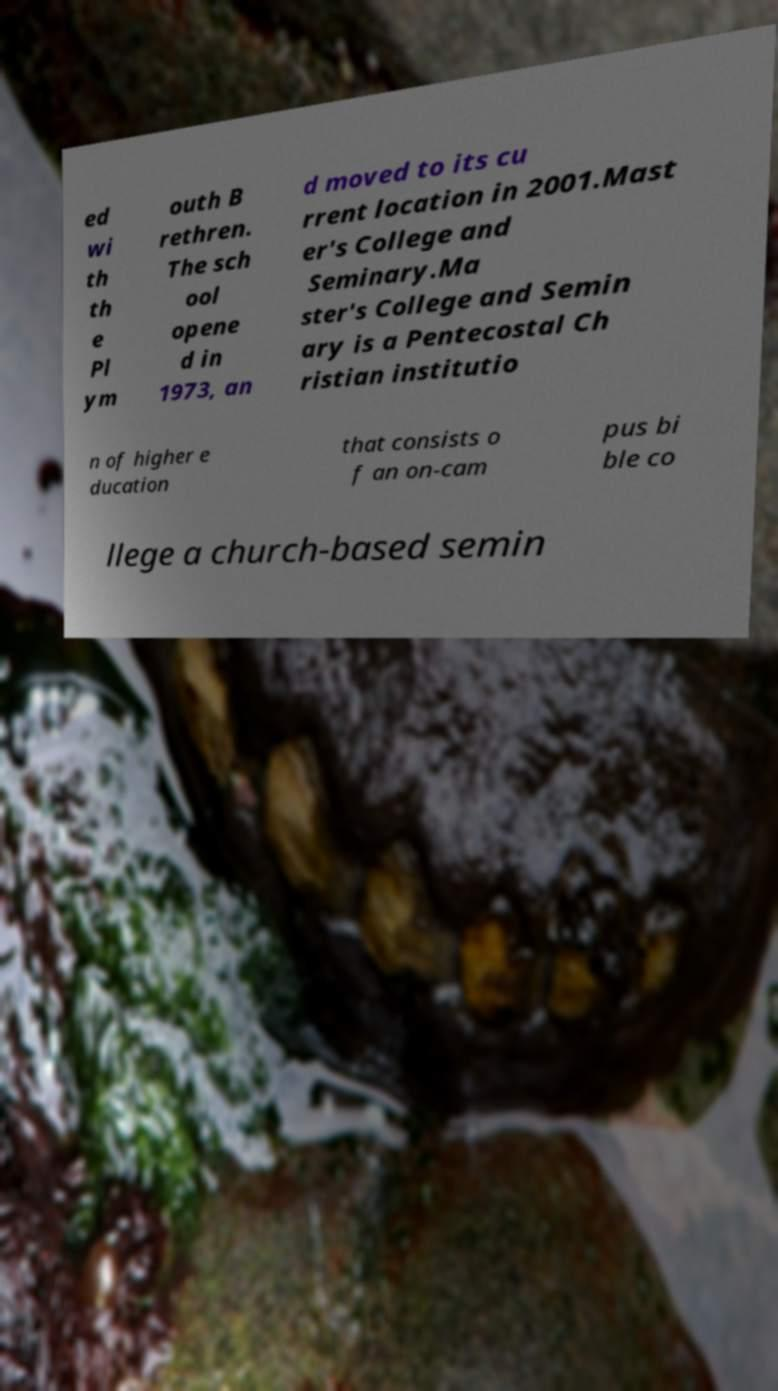Could you assist in decoding the text presented in this image and type it out clearly? ed wi th th e Pl ym outh B rethren. The sch ool opene d in 1973, an d moved to its cu rrent location in 2001.Mast er's College and Seminary.Ma ster's College and Semin ary is a Pentecostal Ch ristian institutio n of higher e ducation that consists o f an on-cam pus bi ble co llege a church-based semin 